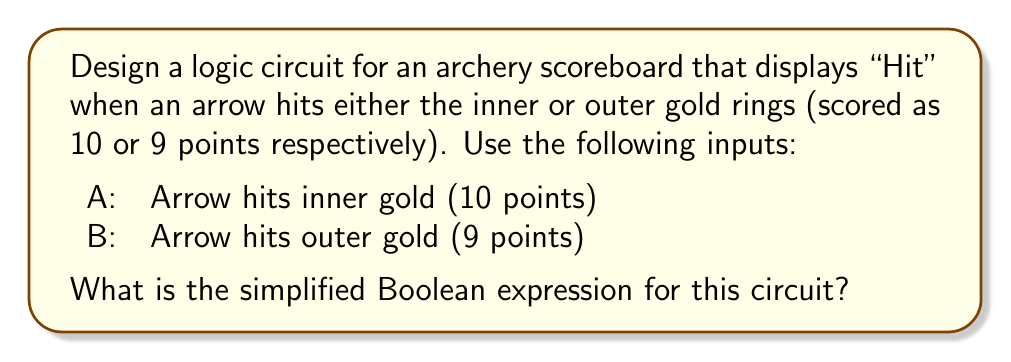Solve this math problem. Let's approach this step-by-step:

1) We need the output to be "Hit" when either A or B is true.

2) This scenario can be represented by the logical OR operation.

3) The Boolean expression for this is:

   $$Hit = A + B$$

   Where '+' represents the OR operation.

4) This expression is already in its simplest form, as it uses only two variables and one operation.

5) In terms of a logic circuit, this would be represented by a single OR gate with inputs A and B.

6) For an archer, this circuit would light up the "Hit" display on the scoreboard whenever an arrow lands in either the inner gold (10 points) or outer gold (9 points) ring, providing immediate feedback on high-scoring shots.
Answer: $A + B$ 